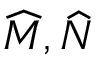<formula> <loc_0><loc_0><loc_500><loc_500>{ \widehat { M } } , { \widehat { N } }</formula> 